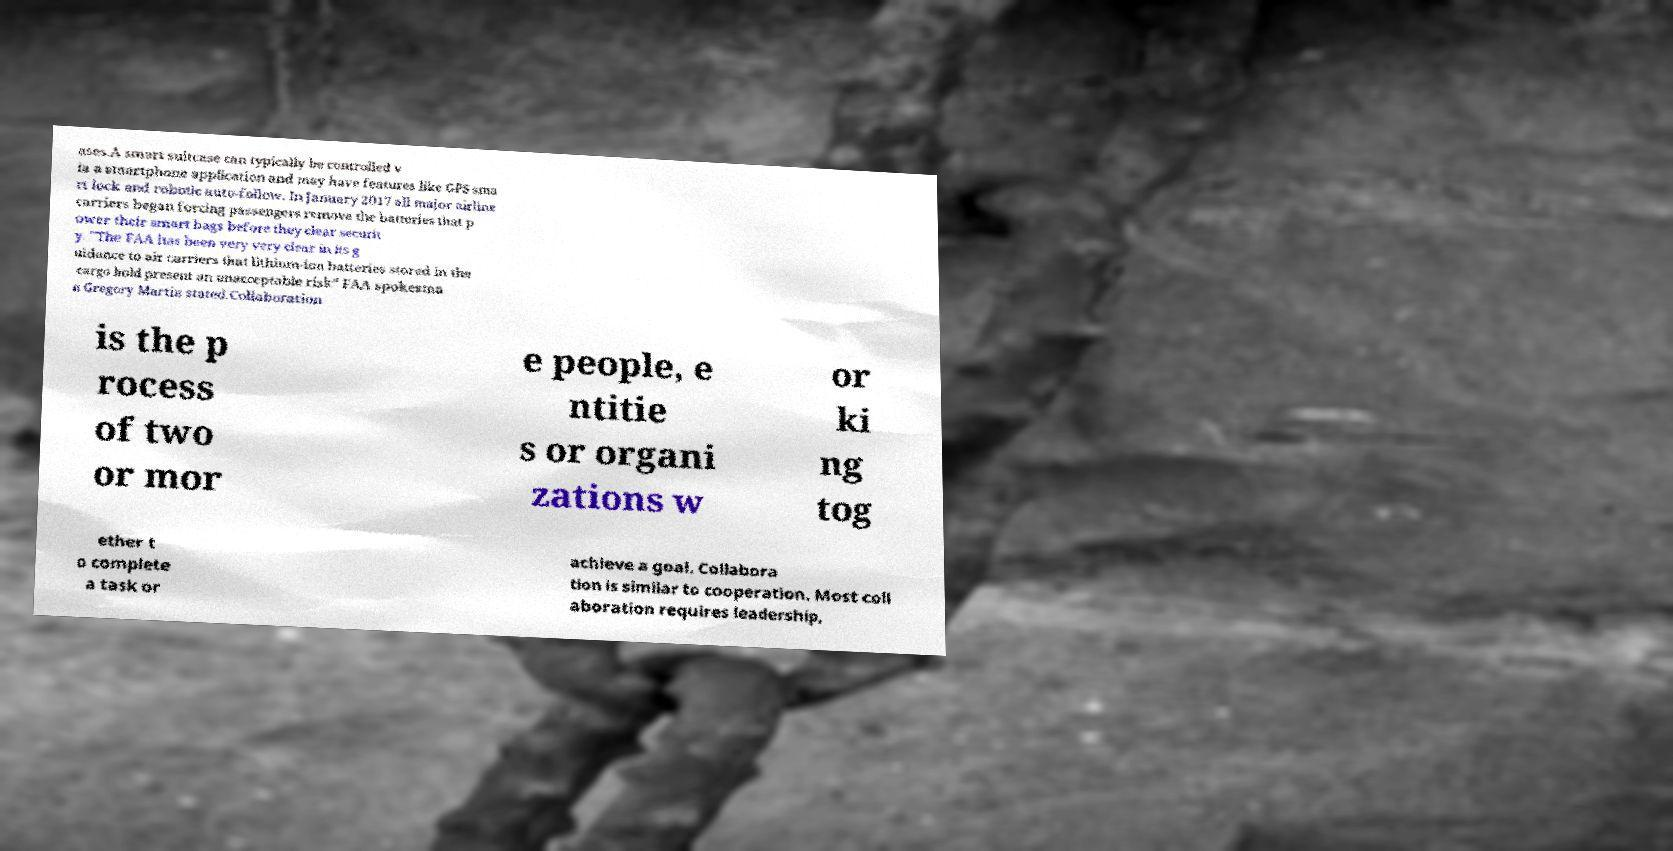For documentation purposes, I need the text within this image transcribed. Could you provide that? ases.A smart suitcase can typically be controlled v ia a smartphone application and may have features like GPS sma rt lock and robotic auto-follow. In January 2017 all major airline carriers began forcing passengers remove the batteries that p ower their smart bags before they clear securit y. "The FAA has been very very clear in its g uidance to air carriers that lithium-ion batteries stored in the cargo hold present an unacceptable risk” FAA spokesma n Gregory Martin stated.Collaboration is the p rocess of two or mor e people, e ntitie s or organi zations w or ki ng tog ether t o complete a task or achieve a goal. Collabora tion is similar to cooperation. Most coll aboration requires leadership, 